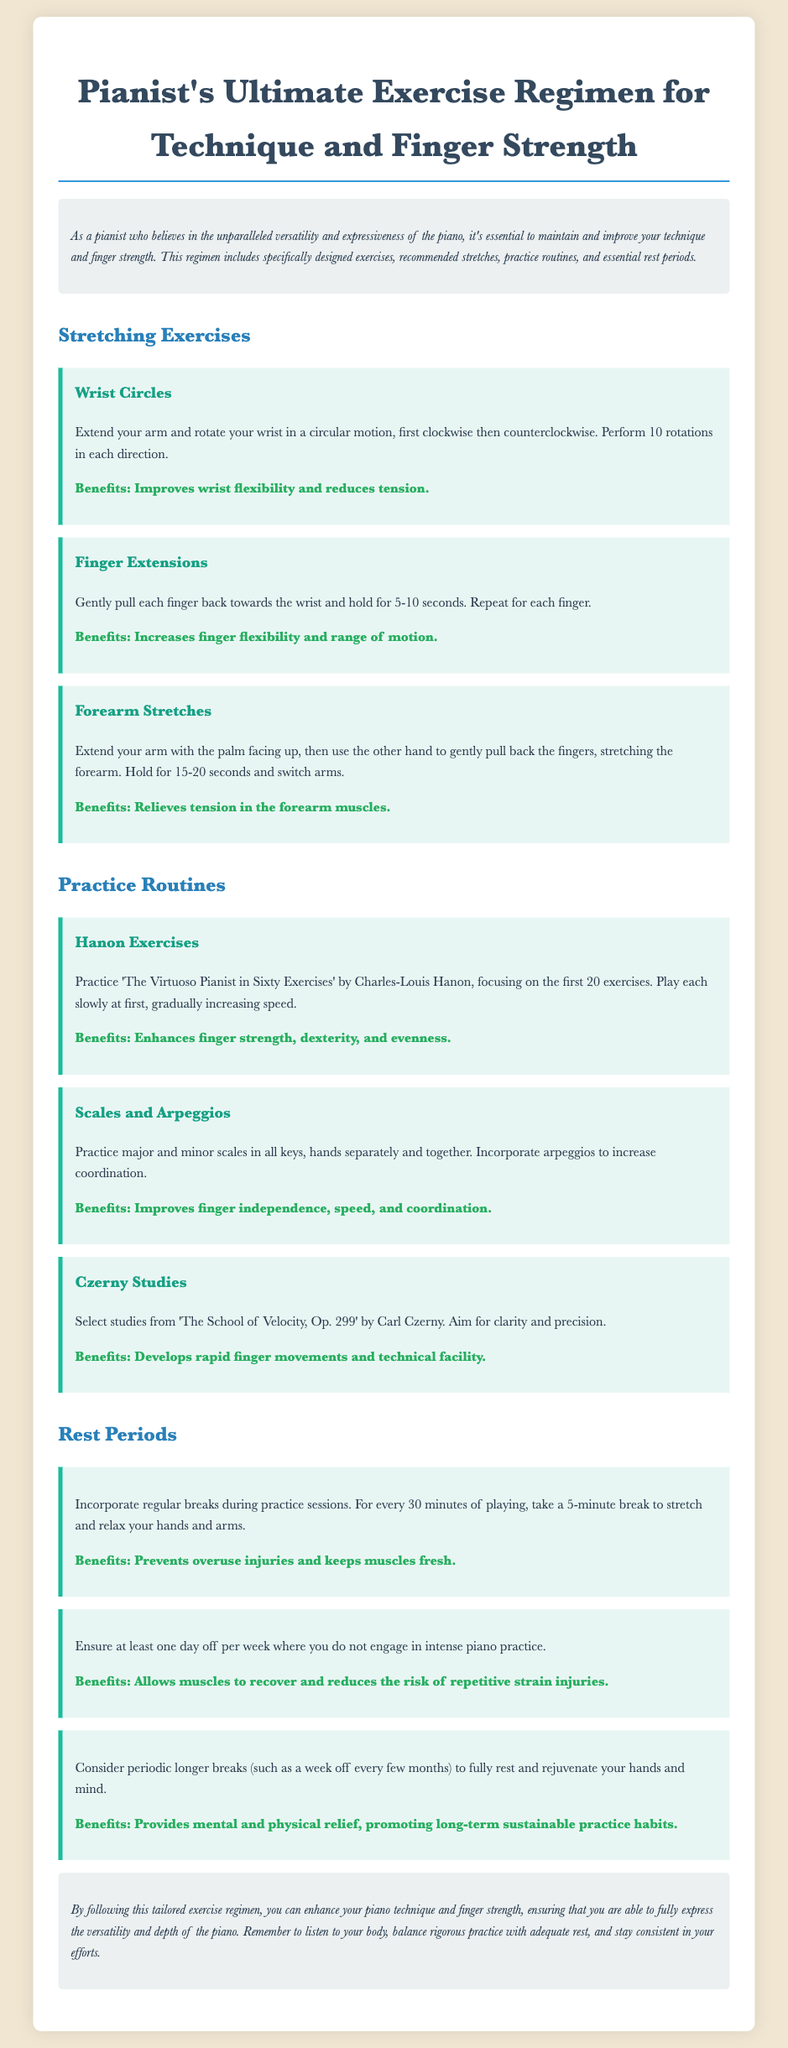What are the benefits of wrist circles? The benefits are stated in the document as improving wrist flexibility and reducing tension.
Answer: Improves wrist flexibility and reduces tension How long should you hold finger extensions? The duration for holding finger extensions is specified in the document as 5-10 seconds.
Answer: 5-10 seconds What is the first routine mentioned in the practice section? The first practice routine listed in the document is Hanon exercises.
Answer: Hanon exercises What should you do after every 30 minutes of practice? The document advises to take a 5-minute break to stretch and relax your hands and arms after every 30 minutes of playing.
Answer: Take a 5-minute break What is recommended once a week in terms of practice? The document recommends ensuring at least one day off per week from intense piano practice.
Answer: One day off per week Which exercise involves rotating the wrist? The exercise that involves rotating the wrist is categorized as wrist circles in the document.
Answer: Wrist circles 